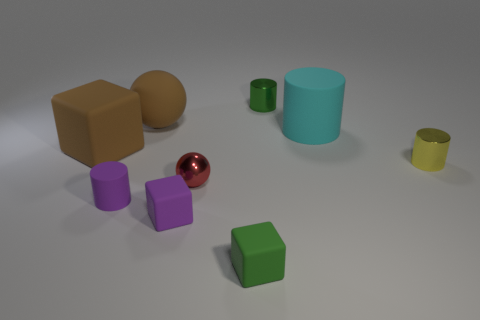How many other small objects have the same shape as the tiny green metallic thing?
Give a very brief answer. 2. What is the material of the large brown thing that is the same shape as the green matte thing?
Give a very brief answer. Rubber. Is the number of tiny metal cylinders that are right of the tiny green cylinder greater than the number of purple rubber objects?
Your answer should be very brief. No. What number of objects are green cylinders or small purple rubber cubes?
Make the answer very short. 2. The big rubber ball has what color?
Offer a terse response. Brown. What number of other things are the same color as the rubber sphere?
Provide a succinct answer. 1. There is a tiny yellow metal cylinder; are there any tiny green rubber blocks behind it?
Provide a short and direct response. No. What color is the small metal thing right of the tiny green thing behind the tiny cylinder in front of the yellow metal object?
Your answer should be very brief. Yellow. What number of things are behind the tiny sphere and on the left side of the small yellow metal cylinder?
Make the answer very short. 4. What number of spheres are either cyan rubber things or yellow things?
Give a very brief answer. 0. 